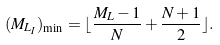Convert formula to latex. <formula><loc_0><loc_0><loc_500><loc_500>( M _ { L _ { I } } ) _ { \min } = \lfloor \frac { M _ { L } - 1 } { N } + \frac { N + 1 } { 2 } \rfloor .</formula> 